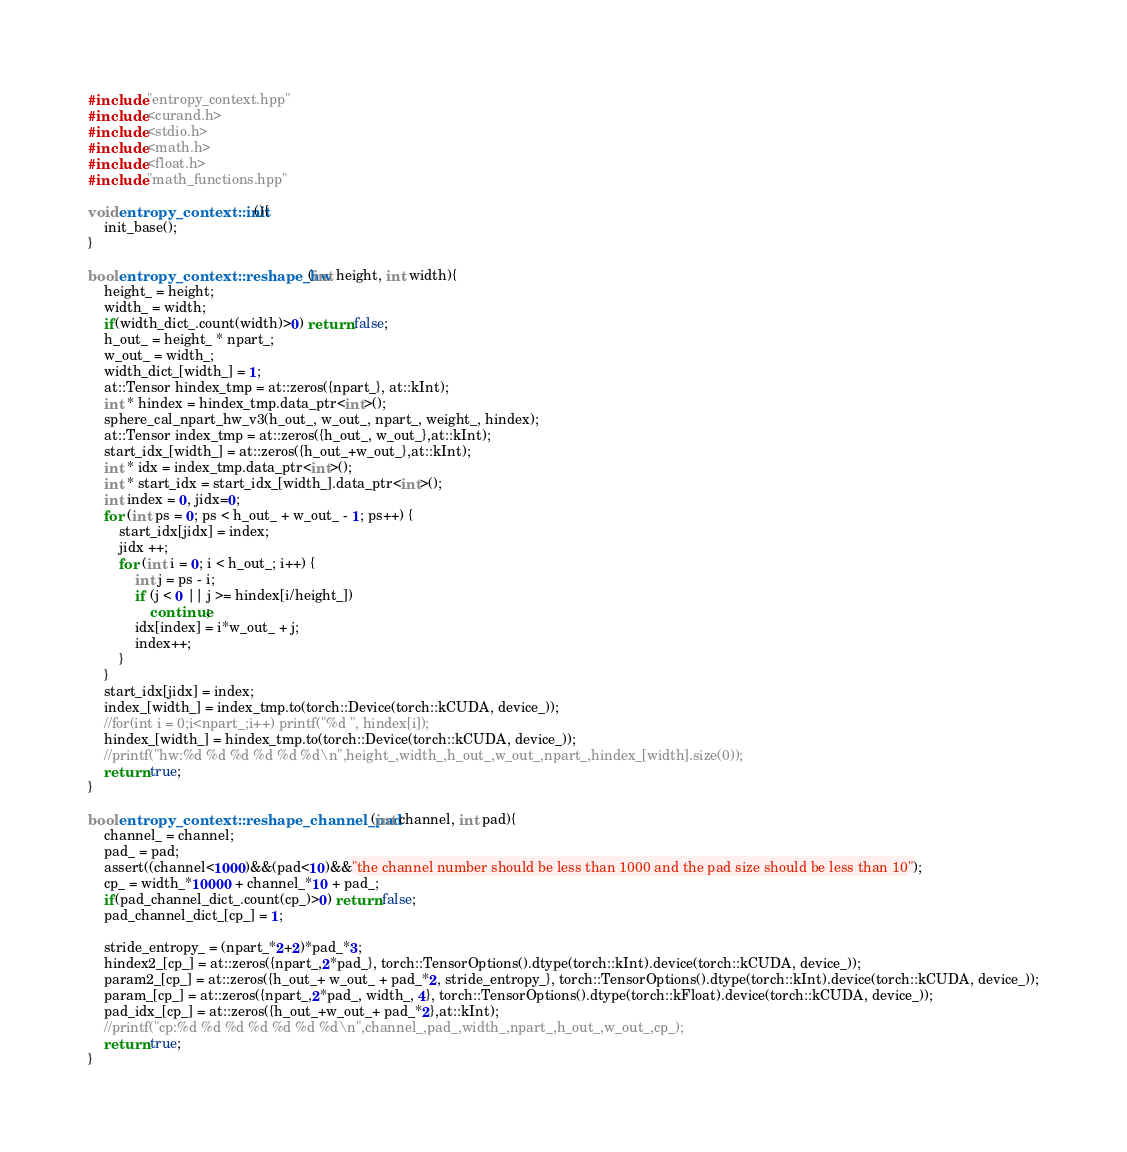<code> <loc_0><loc_0><loc_500><loc_500><_Cuda_>
#include "entropy_context.hpp"
#include <curand.h>
#include <stdio.h>
#include <math.h>
#include <float.h>
#include "math_functions.hpp"

void entropy_context::init(){
    init_base();
}

bool entropy_context::reshape_hw(int height, int width){
    height_ = height;
    width_ = width;
    if(width_dict_.count(width)>0) return false;
    h_out_ = height_ * npart_;
    w_out_ = width_;
    width_dict_[width_] = 1;
    at::Tensor hindex_tmp = at::zeros({npart_}, at::kInt);
    int * hindex = hindex_tmp.data_ptr<int>();
    sphere_cal_npart_hw_v3(h_out_, w_out_, npart_, weight_, hindex);
    at::Tensor index_tmp = at::zeros({h_out_, w_out_},at::kInt);
    start_idx_[width_] = at::zeros({h_out_+w_out_},at::kInt);
    int * idx = index_tmp.data_ptr<int>();
    int * start_idx = start_idx_[width_].data_ptr<int>();
    int index = 0, jidx=0;
    for (int ps = 0; ps < h_out_ + w_out_ - 1; ps++) {
        start_idx[jidx] = index;
        jidx ++;
        for (int i = 0; i < h_out_; i++) {
            int j = ps - i;
            if (j < 0 || j >= hindex[i/height_])
                continue;
            idx[index] = i*w_out_ + j;
            index++;
        }
    }
    start_idx[jidx] = index;
    index_[width_] = index_tmp.to(torch::Device(torch::kCUDA, device_));
    //for(int i = 0;i<npart_;i++) printf("%d ", hindex[i]);
    hindex_[width_] = hindex_tmp.to(torch::Device(torch::kCUDA, device_));
    //printf("hw:%d %d %d %d %d %d\n",height_,width_,h_out_,w_out_,npart_,hindex_[width].size(0));
    return true;
}

bool entropy_context::reshape_channel_pad(int channel, int pad){
    channel_ = channel; 
    pad_ = pad;
    assert((channel<1000)&&(pad<10)&&"the channel number should be less than 1000 and the pad size should be less than 10");
    cp_ = width_*10000 + channel_*10 + pad_;
    if(pad_channel_dict_.count(cp_)>0) return false;
    pad_channel_dict_[cp_] = 1;
    
    stride_entropy_ = (npart_*2+2)*pad_*3;
    hindex2_[cp_] = at::zeros({npart_,2*pad_}, torch::TensorOptions().dtype(torch::kInt).device(torch::kCUDA, device_));
    param2_[cp_] = at::zeros({h_out_+ w_out_ + pad_*2, stride_entropy_}, torch::TensorOptions().dtype(torch::kInt).device(torch::kCUDA, device_));
    param_[cp_] = at::zeros({npart_,2*pad_, width_, 4}, torch::TensorOptions().dtype(torch::kFloat).device(torch::kCUDA, device_));
    pad_idx_[cp_] = at::zeros({h_out_+w_out_+ pad_*2},at::kInt);
    //printf("cp:%d %d %d %d %d %d %d\n",channel_,pad_,width_,npart_,h_out_,w_out_,cp_);
    return true;
}
</code> 